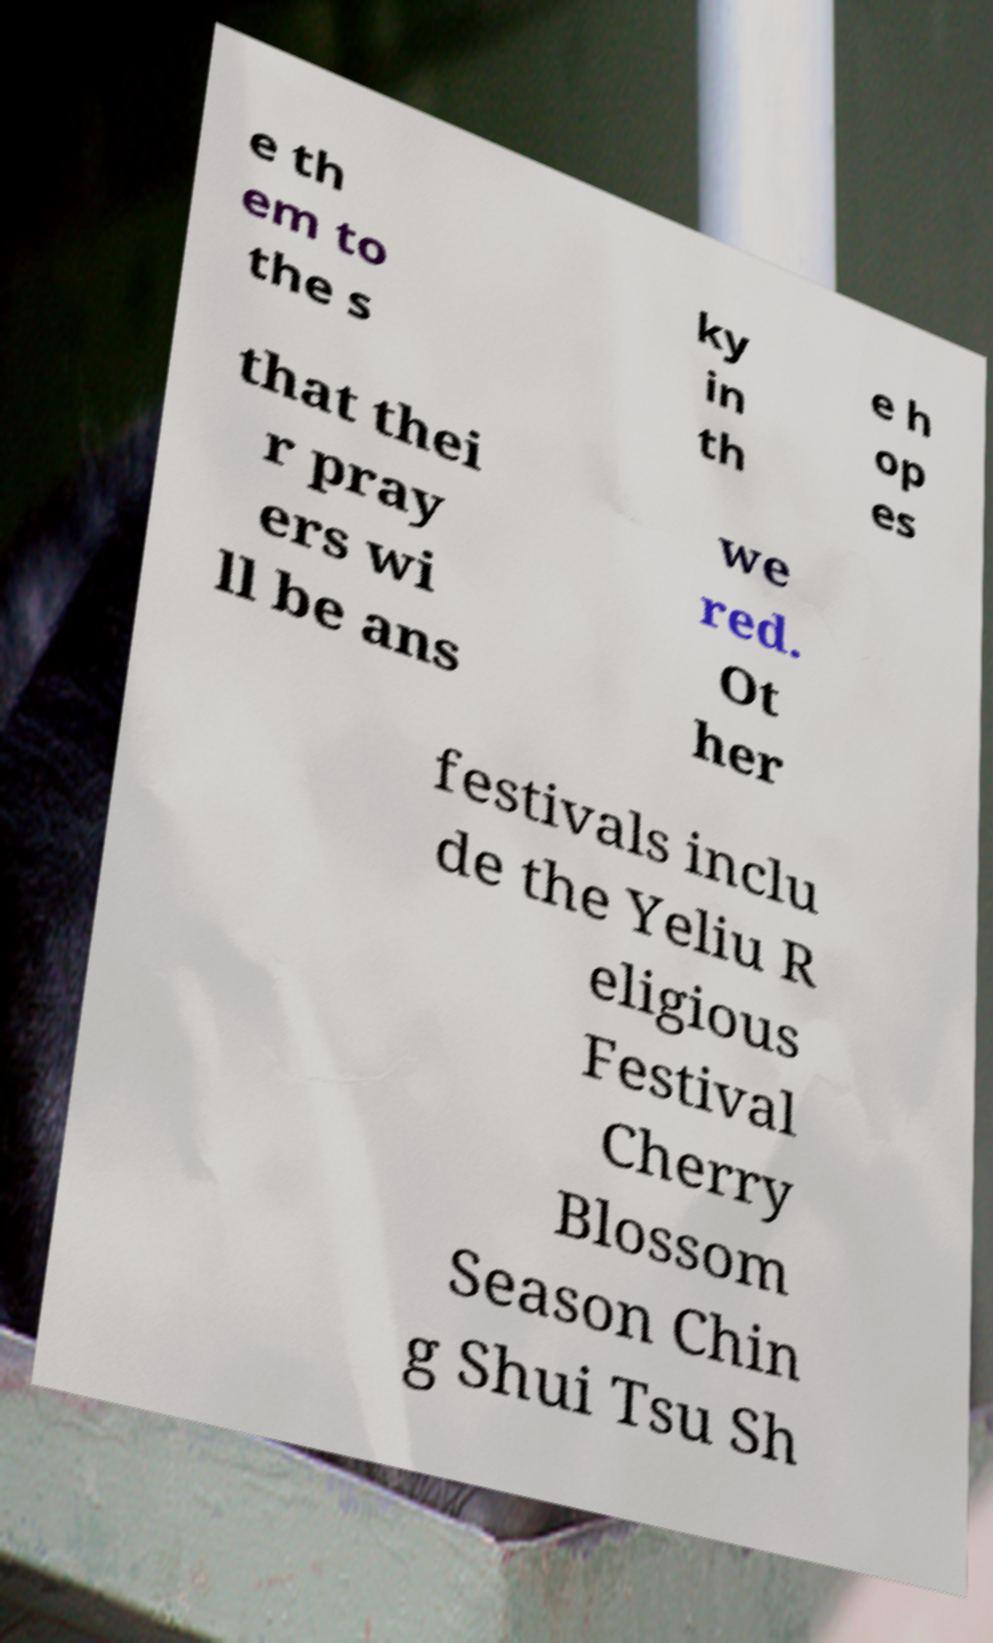Please identify and transcribe the text found in this image. e th em to the s ky in th e h op es that thei r pray ers wi ll be ans we red. Ot her festivals inclu de the Yeliu R eligious Festival Cherry Blossom Season Chin g Shui Tsu Sh 